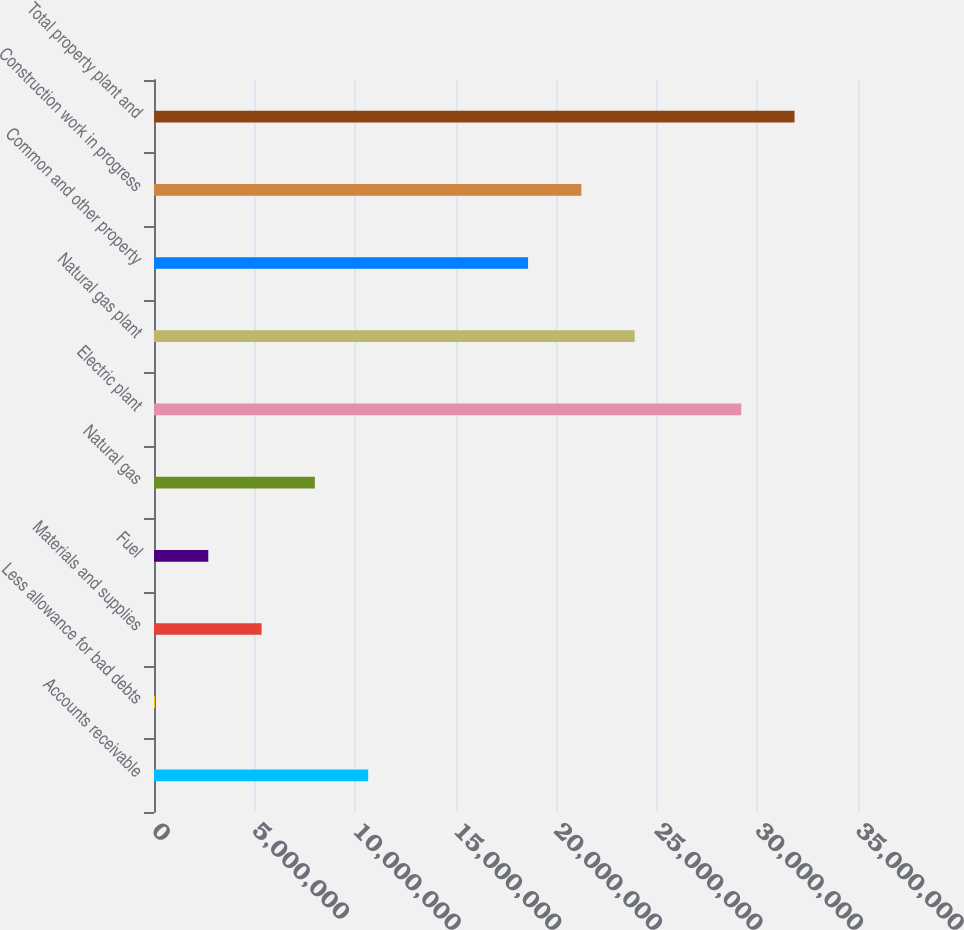<chart> <loc_0><loc_0><loc_500><loc_500><bar_chart><fcel>Accounts receivable<fcel>Less allowance for bad debts<fcel>Materials and supplies<fcel>Fuel<fcel>Natural gas<fcel>Electric plant<fcel>Natural gas plant<fcel>Common and other property<fcel>Construction work in progress<fcel>Total property plant and<nl><fcel>1.06479e+07<fcel>49401<fcel>5.34867e+06<fcel>2.69904e+06<fcel>7.99831e+06<fcel>2.91954e+07<fcel>2.38961e+07<fcel>1.85969e+07<fcel>2.12465e+07<fcel>3.1845e+07<nl></chart> 